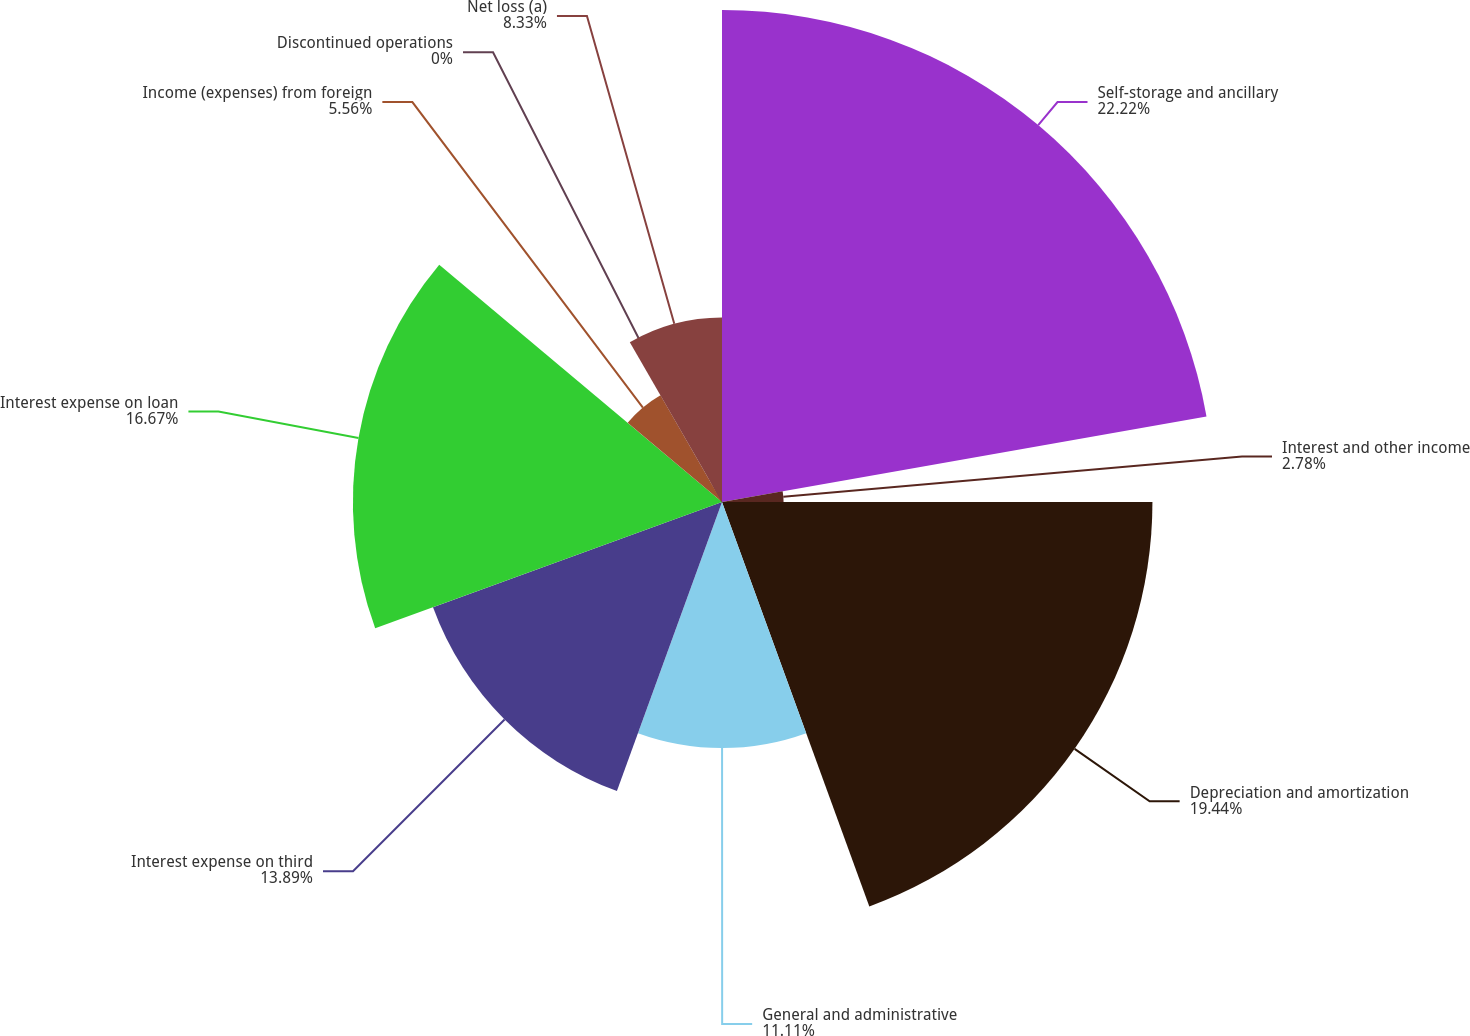<chart> <loc_0><loc_0><loc_500><loc_500><pie_chart><fcel>Self-storage and ancillary<fcel>Interest and other income<fcel>Depreciation and amortization<fcel>General and administrative<fcel>Interest expense on third<fcel>Interest expense on loan<fcel>Income (expenses) from foreign<fcel>Discontinued operations<fcel>Net loss (a)<nl><fcel>22.22%<fcel>2.78%<fcel>19.44%<fcel>11.11%<fcel>13.89%<fcel>16.67%<fcel>5.56%<fcel>0.0%<fcel>8.33%<nl></chart> 